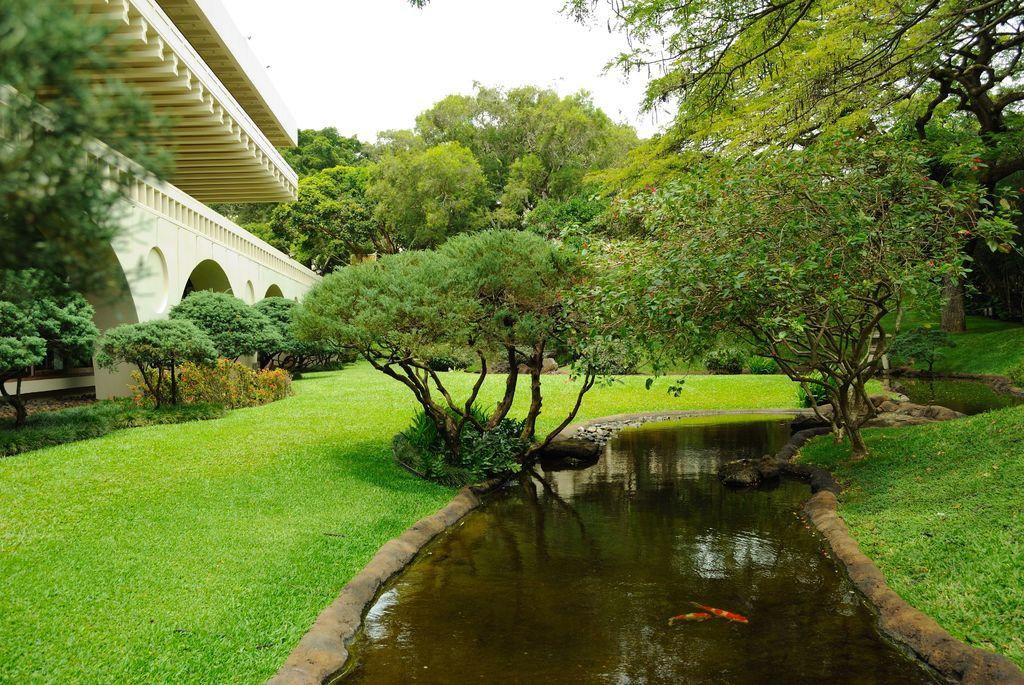What type of animals can be seen in the water in the image? There are fish in the water in the image. What type of structure is visible in the image? There is a building visible in the image. What type of vegetation is present in the image? Plants and trees are present in the image. What part of the natural environment is visible in the image? The sky is visible in the background of the image. How many children are holding hands in the image? There are no children present in the image. What type of rest can be seen in the image? There is no rest visible in the image; it features fish in the water, a building, plants, trees, and the sky. 